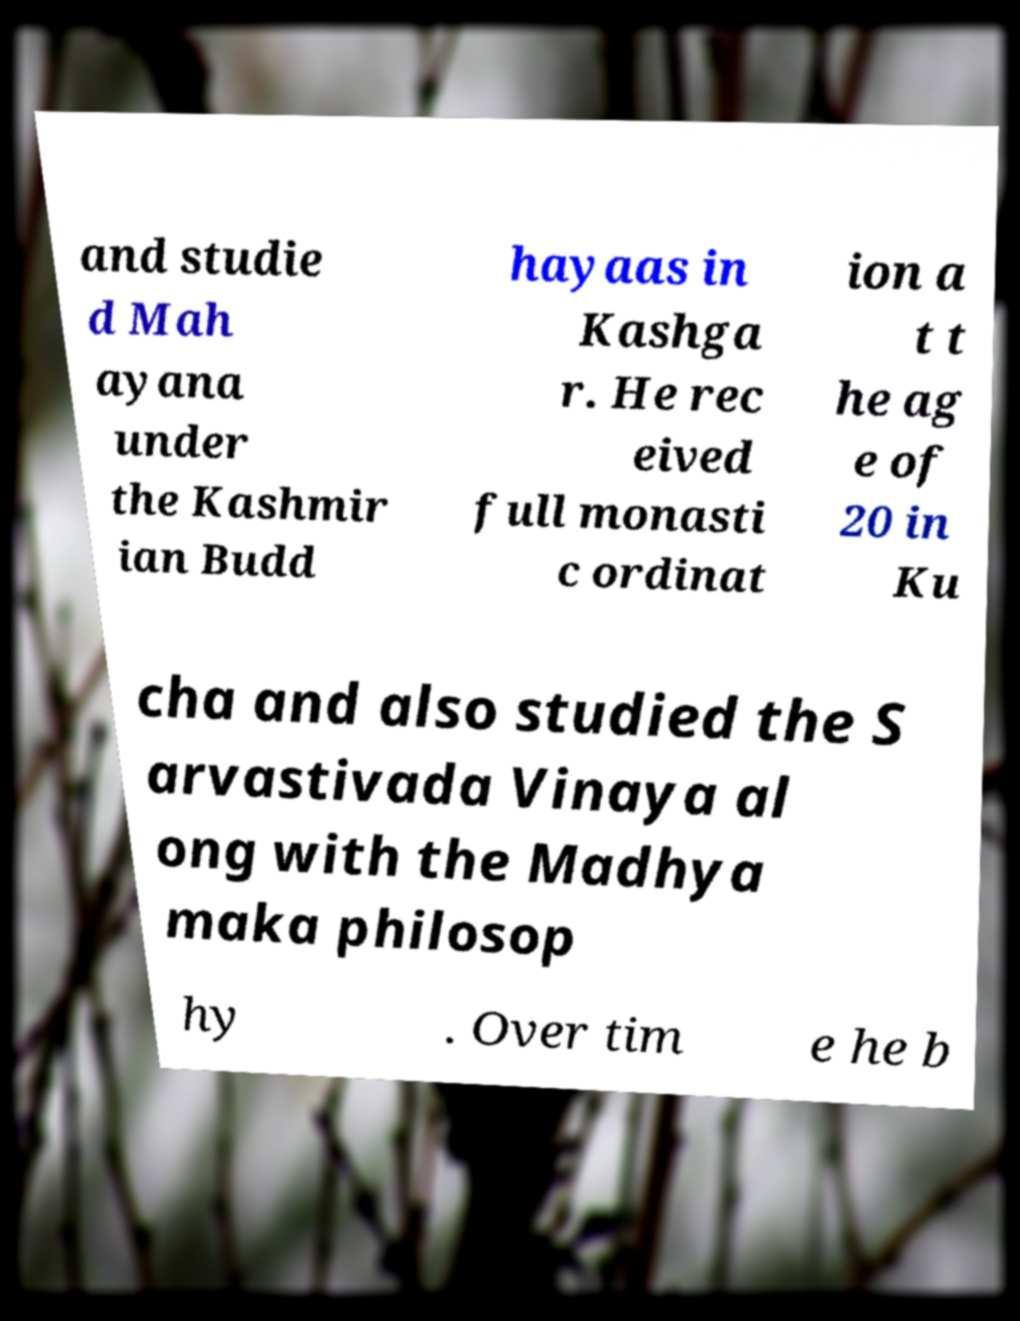Please identify and transcribe the text found in this image. and studie d Mah ayana under the Kashmir ian Budd hayaas in Kashga r. He rec eived full monasti c ordinat ion a t t he ag e of 20 in Ku cha and also studied the S arvastivada Vinaya al ong with the Madhya maka philosop hy . Over tim e he b 